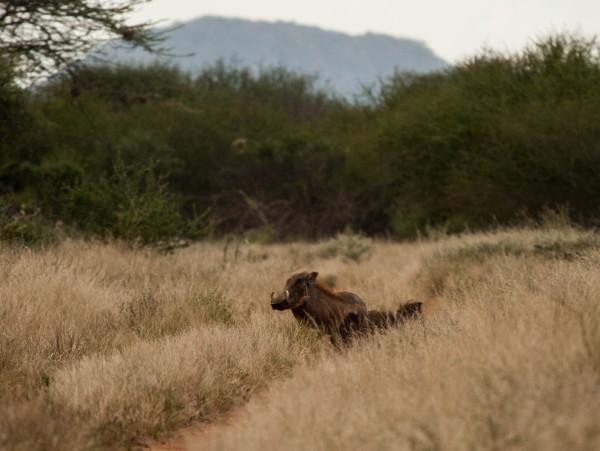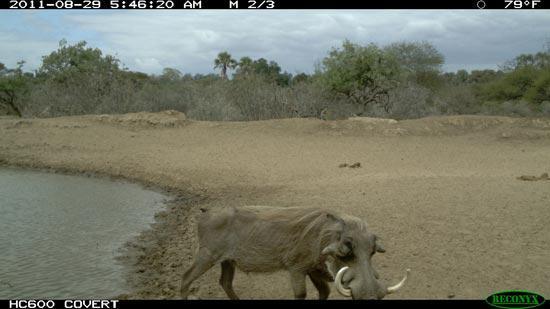The first image is the image on the left, the second image is the image on the right. For the images shown, is this caption "One of the images shows an animal in close proximity to water." true? Answer yes or no. Yes. The first image is the image on the left, the second image is the image on the right. Assess this claim about the two images: "All the animals appear in front of a completely green background.". Correct or not? Answer yes or no. No. 